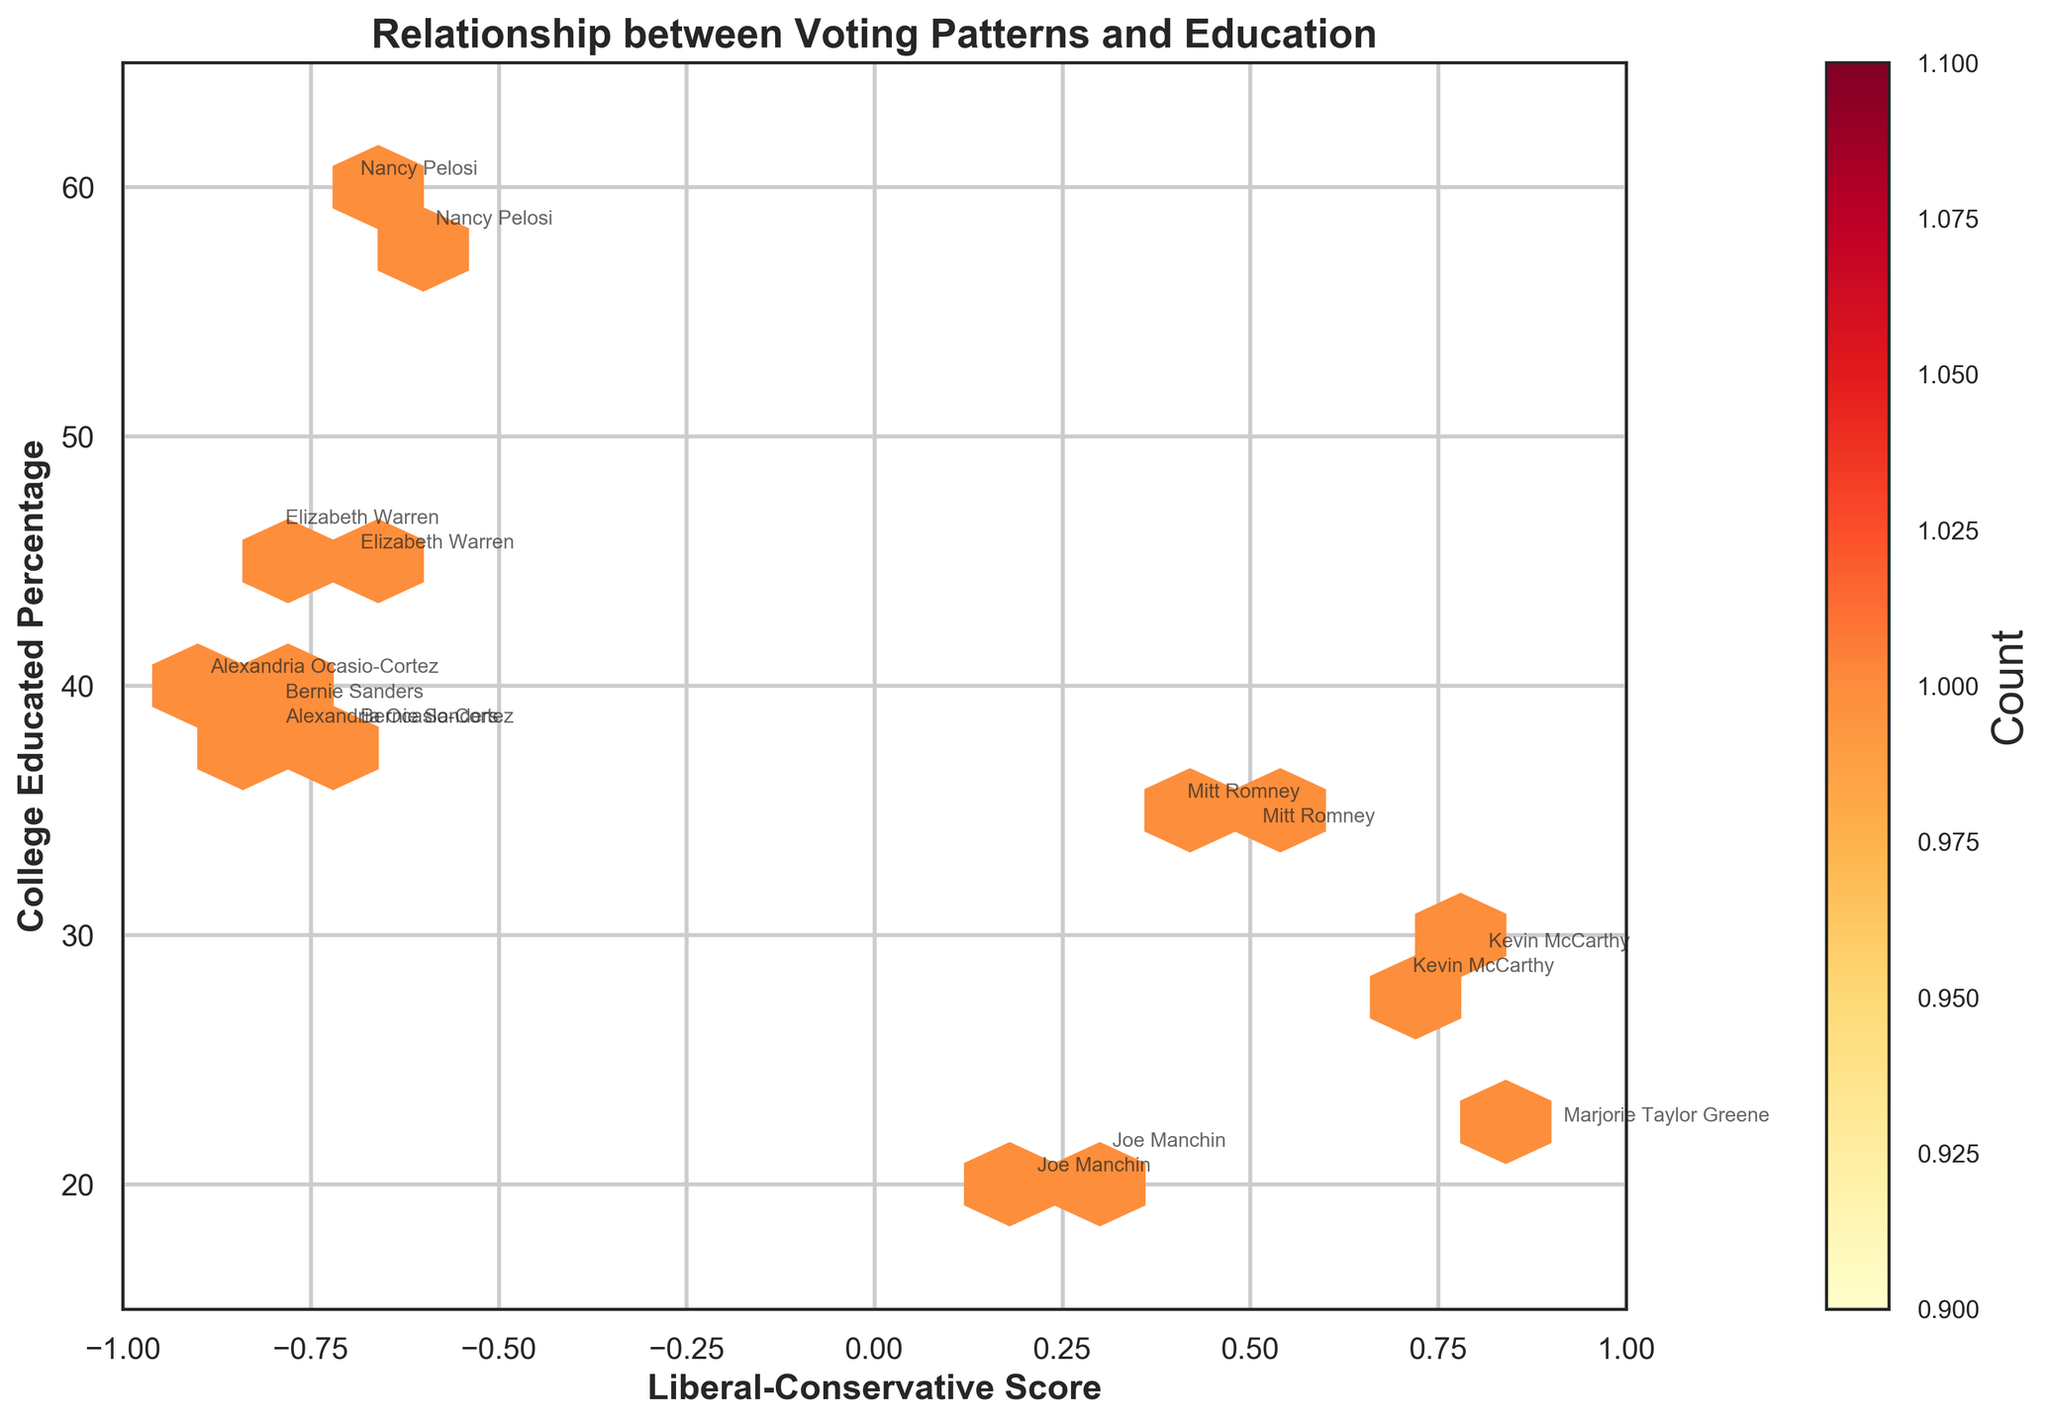What is the title of the figure? The title of the figure is displayed prominently at the top and is often in a larger or bold font compared to other text.
Answer: Relationship between Voting Patterns and Education What are the ranges of the x and y axes? The x-axis range goes from -1 to 1, as evident from the labeled tick marks on the axis. The y-axis range goes from 15 to 65, also shown by the labeled tick marks.
Answer: x-axis: -1 to 1, y-axis: 15 to 65 Which legislator has the most college-educated constituency? To determine this, look at the annotated names on the plot and identify which has the highest y-value (College Educated Percentage).
Answer: Nancy Pelosi Are there more legislators with a conservative or liberal voting pattern? To answer, count the number of data points (hexagons) on the negative side of the x-axis (liberal) and the positive side (conservative).
Answer: Liberal What is the highest count of data points in a single hexbin? The color bar on the right side indicates the counts, with the color gradient showing different levels. Identify the darkest color on the plot and match it to the color bar.
Answer: 1 How does the College-Educated Percentage vary with the Liberal-Conservative Score? Observing the general trend in the hexbin plot shows whether higher College Educated Percentages coincide with more liberal or conservative scores, or if it is more distributed.
Answer: More liberal areas tend to have higher College Educated Percentages Which term (2019-2021 or 2021-2023) has the higher college-educated percentage for Alexandria Ocasio-Cortez's constituency? Compare the annotated values for Alexandria Ocasio-Cortez for the two terms on the y-axis.
Answer: 2021-2023 Which legislator represents a constituency with a median income close to $70,000? Use the annotated names to identify the legislator whose y-value (College Educated Percentage) aligns with the constituency's attributes provided.
Answer: Mitt Romney What is the relationship between liberal-conservative score and median age? This requires cross-referencing the liberal-conservative score with the provided data to interpret any visible pattern or lack thereof. Annotations and hexbin counts provide visual insight.
Answer: No clear pattern discernible from the figure Is there a legislator whose liberal-conservative score changed significantly over the terms? Compare the positions of annotated data points for the same legislator across different terms on the x-axis.
Answer: No significant changes 